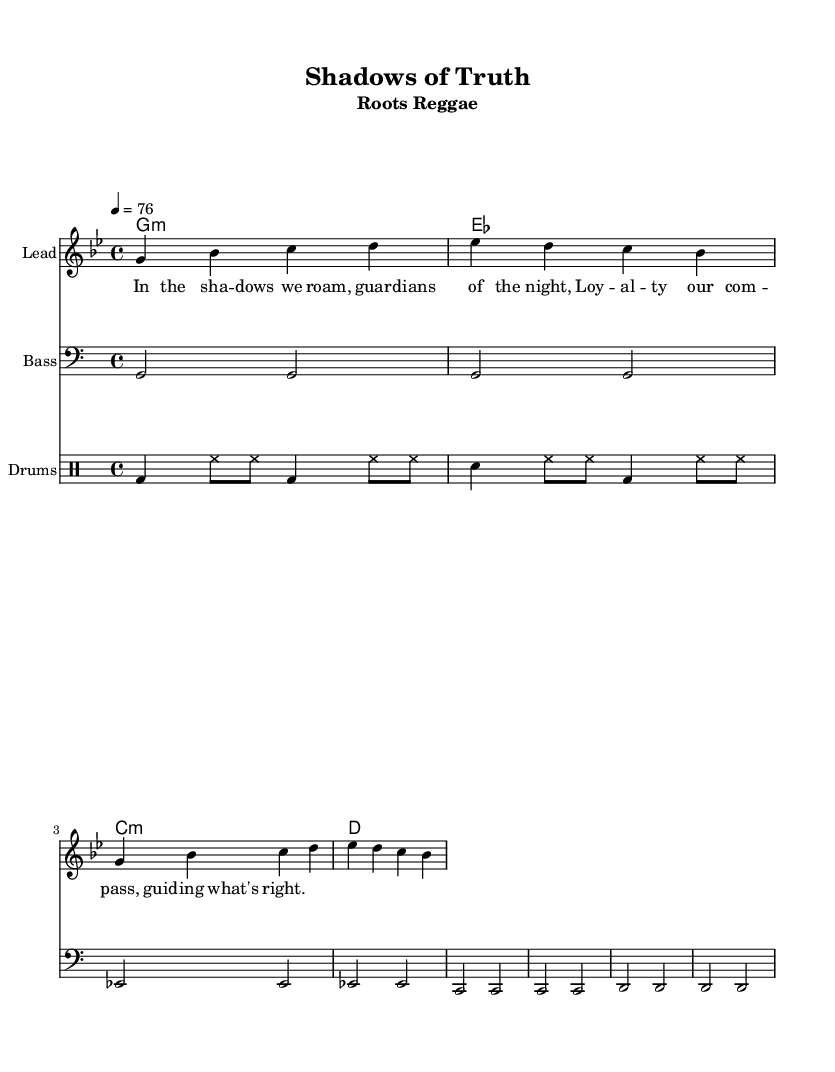What is the key signature of this music? The key signature is G minor, which includes two flats (B flat and E flat).
Answer: G minor What is the time signature of the music? The time signature is indicated at the beginning of the score and shows how many beats are in each measure. It is 4/4, meaning there are four beats per measure.
Answer: 4/4 What is the tempo marking for this piece? The tempo marking is indicated as "4 = 76," which signifies a brisk pace at 76 beats per minute.
Answer: 76 How many measures are in the melody? The melody consists of two repeated phrases, and each phrase contains four measures, totaling eight measures.
Answer: 8 What is the primary theme reflected in the lyrics? The lyrics emphasize loyalty and ethical decision-making in guidance, addressing themes of secrecy and truth in challenging circumstances.
Answer: Loyalty and ethics How does the bassline relate to the melody? The bassline provides a foundational harmonic structure that supports the melody, often playing root notes of the underlying chords. This relationship is essential in reggae music.
Answer: Harmonic support What characterizes the rhythm of the drum part? The drum part combines bass drums, snare drums, and hi-hats in a syncopated pattern, typical for reggae, creating a laid-back groove that complements the bassline and melody.
Answer: Syncopated groove 